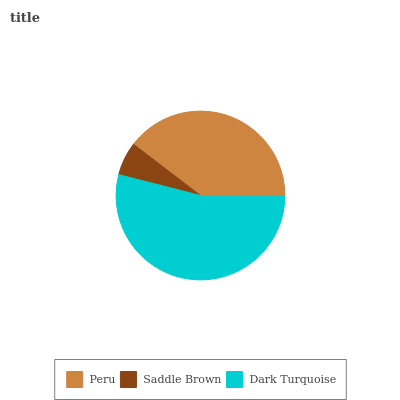Is Saddle Brown the minimum?
Answer yes or no. Yes. Is Dark Turquoise the maximum?
Answer yes or no. Yes. Is Dark Turquoise the minimum?
Answer yes or no. No. Is Saddle Brown the maximum?
Answer yes or no. No. Is Dark Turquoise greater than Saddle Brown?
Answer yes or no. Yes. Is Saddle Brown less than Dark Turquoise?
Answer yes or no. Yes. Is Saddle Brown greater than Dark Turquoise?
Answer yes or no. No. Is Dark Turquoise less than Saddle Brown?
Answer yes or no. No. Is Peru the high median?
Answer yes or no. Yes. Is Peru the low median?
Answer yes or no. Yes. Is Saddle Brown the high median?
Answer yes or no. No. Is Saddle Brown the low median?
Answer yes or no. No. 